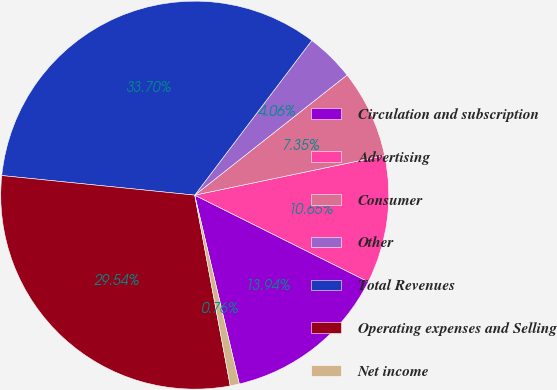<chart> <loc_0><loc_0><loc_500><loc_500><pie_chart><fcel>Circulation and subscription<fcel>Advertising<fcel>Consumer<fcel>Other<fcel>Total Revenues<fcel>Operating expenses and Selling<fcel>Net income<nl><fcel>13.94%<fcel>10.65%<fcel>7.35%<fcel>4.06%<fcel>33.7%<fcel>29.54%<fcel>0.76%<nl></chart> 